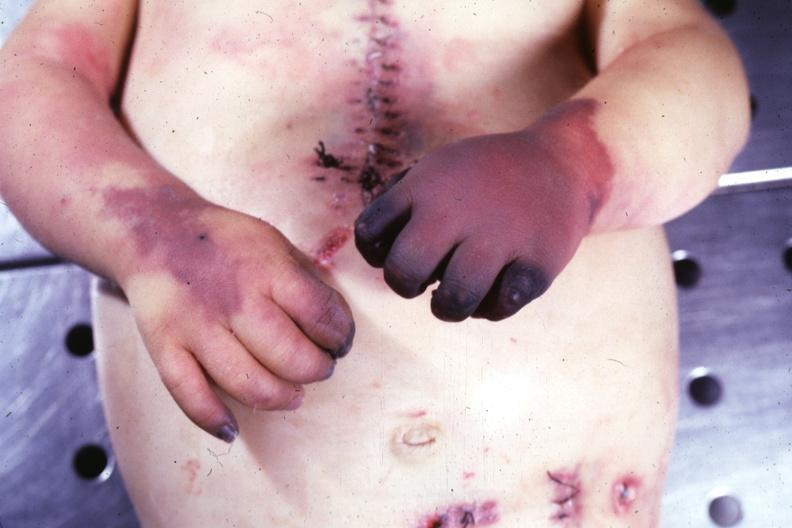re extremities present?
Answer the question using a single word or phrase. Yes 